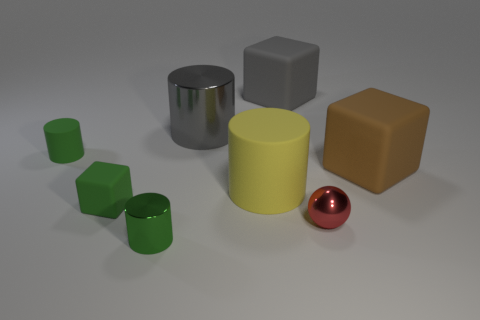Add 1 large gray cubes. How many objects exist? 9 Subtract all cyan cylinders. Subtract all gray cubes. How many cylinders are left? 4 Subtract all spheres. How many objects are left? 7 Add 6 green cylinders. How many green cylinders exist? 8 Subtract 0 yellow blocks. How many objects are left? 8 Subtract all large things. Subtract all large matte cylinders. How many objects are left? 3 Add 4 gray metal things. How many gray metal things are left? 5 